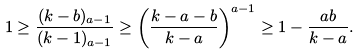<formula> <loc_0><loc_0><loc_500><loc_500>1 \geq \frac { ( k - b ) _ { a - 1 } } { ( k - 1 ) _ { a - 1 } } \geq \left ( \frac { k - a - b } { k - a } \right ) ^ { a - 1 } \geq 1 - \frac { a b } { k - a } .</formula> 